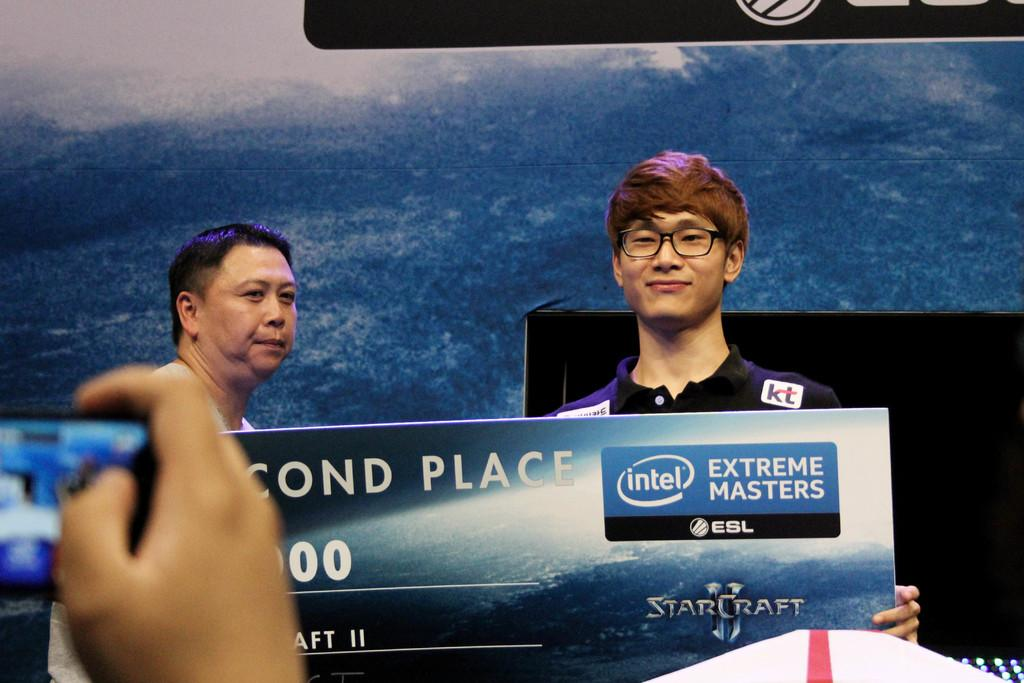What is the person on the left side of the image holding? The person on the left side of the image is holding a mobile. How many people are in the center of the image? There are two persons in the center of the image. What are the two persons in the center of the image doing? The two persons in the center of the image are holding an object. What can be seen in the background of the image? There is a banner in the background of the image. What type of volleyball game is being played in the image? There is no volleyball game present in the image. Who is the coach of the team in the image? There is no team or coach present in the image. 